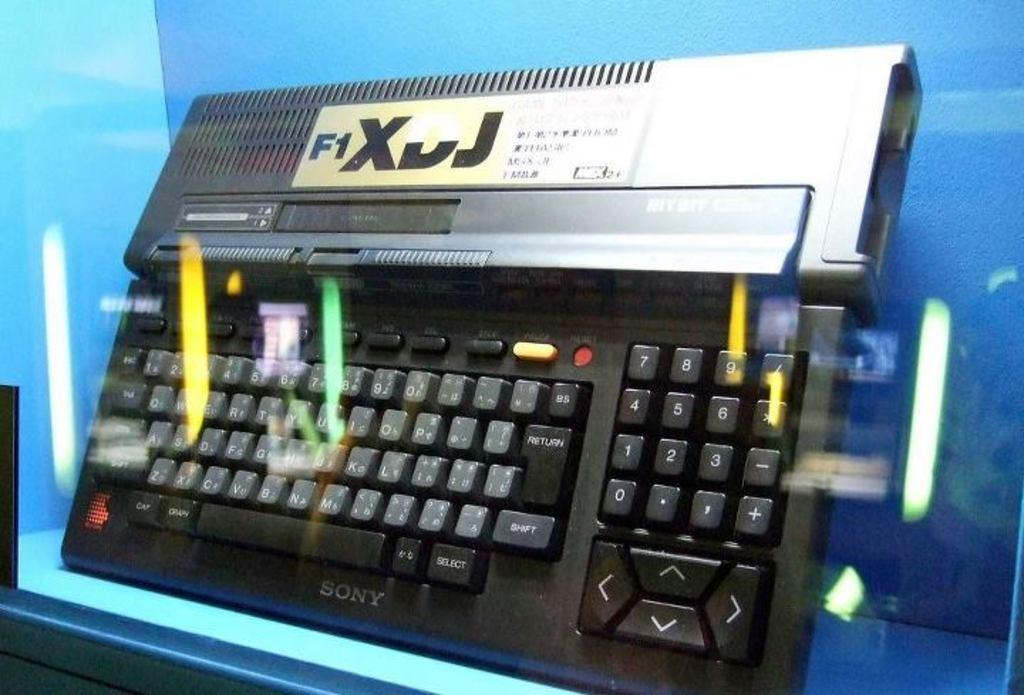What is the main object in the image? There is a keyboard in the image. What is the keyboard placed on? The keyboard is placed on a blue object. How is the image captured? The image is captured through a glass. How many worms can be seen crawling on the keyboard in the image? There are no worms present in the image; it only features a keyboard placed on a blue object and captured through a glass. 